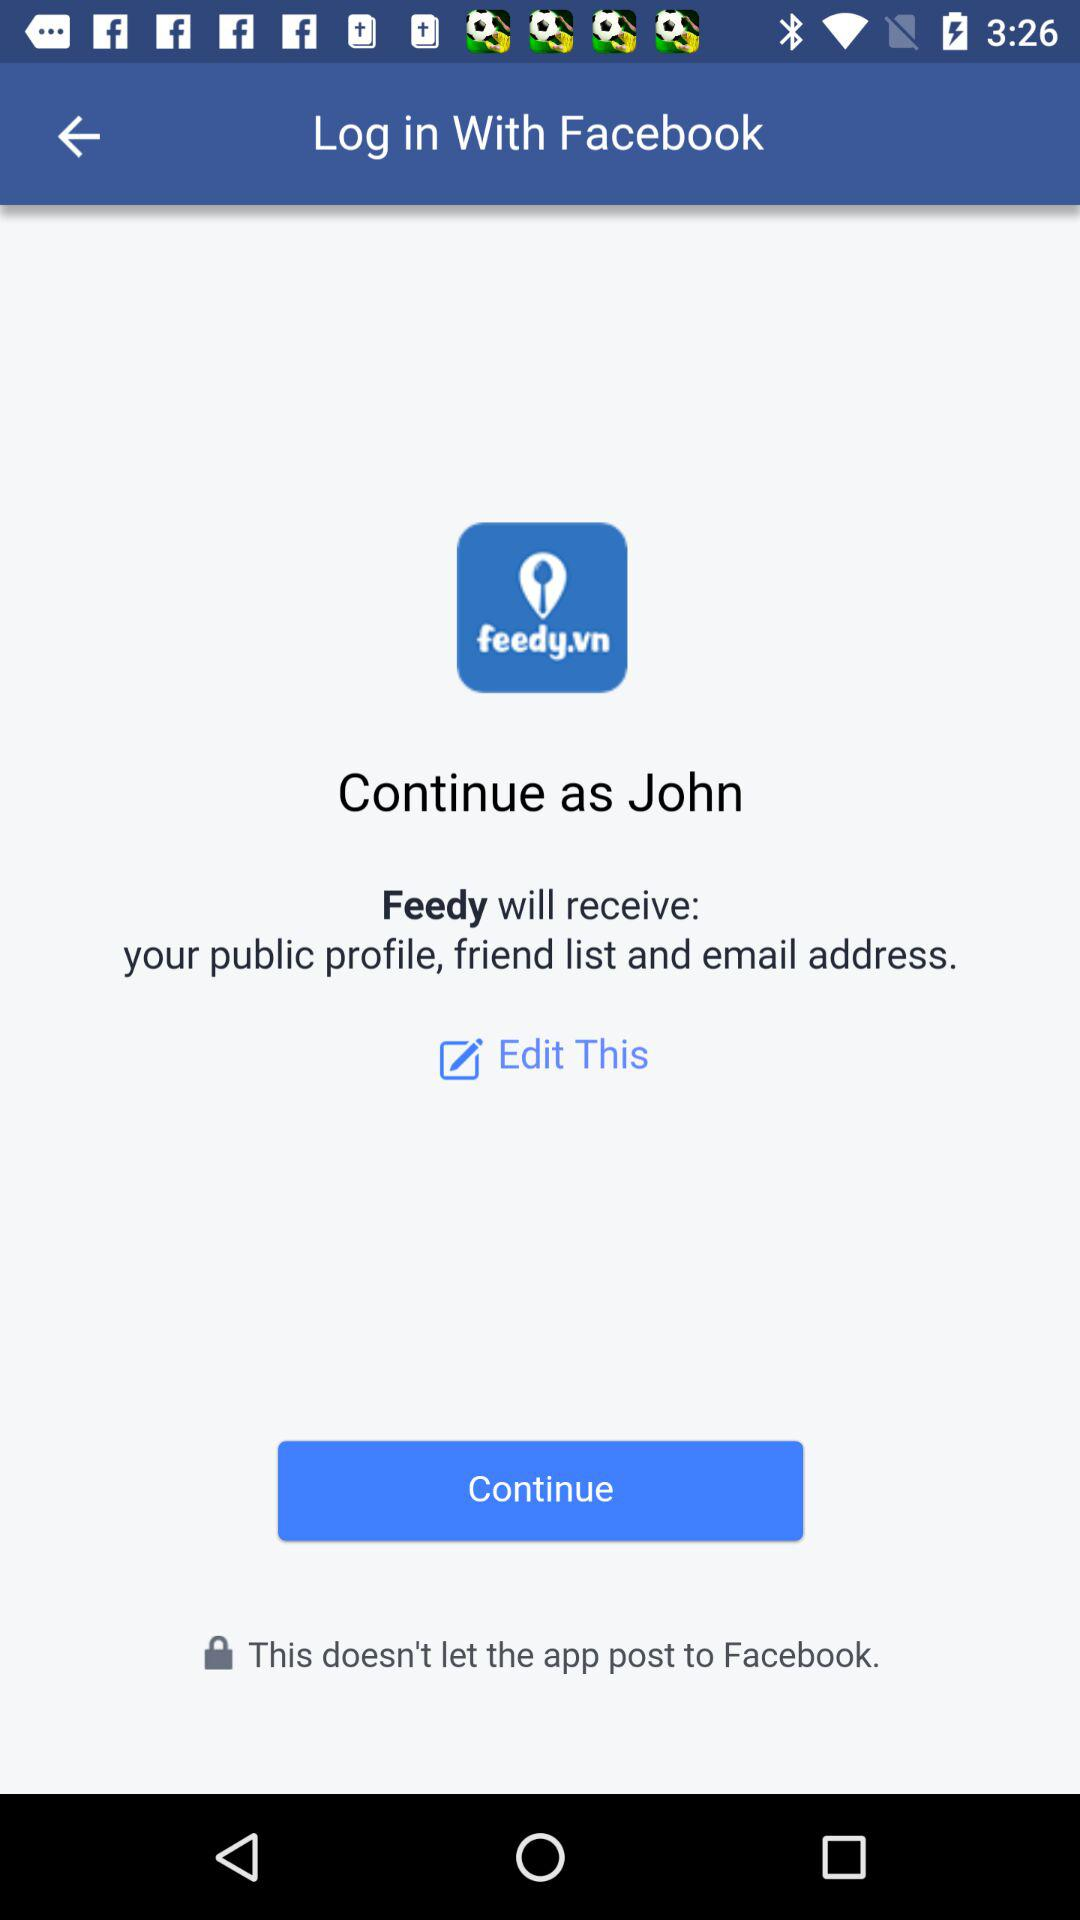Which information will "Feedy" receive? "Feedy" will receive information about your public profile, friend list and email address. 